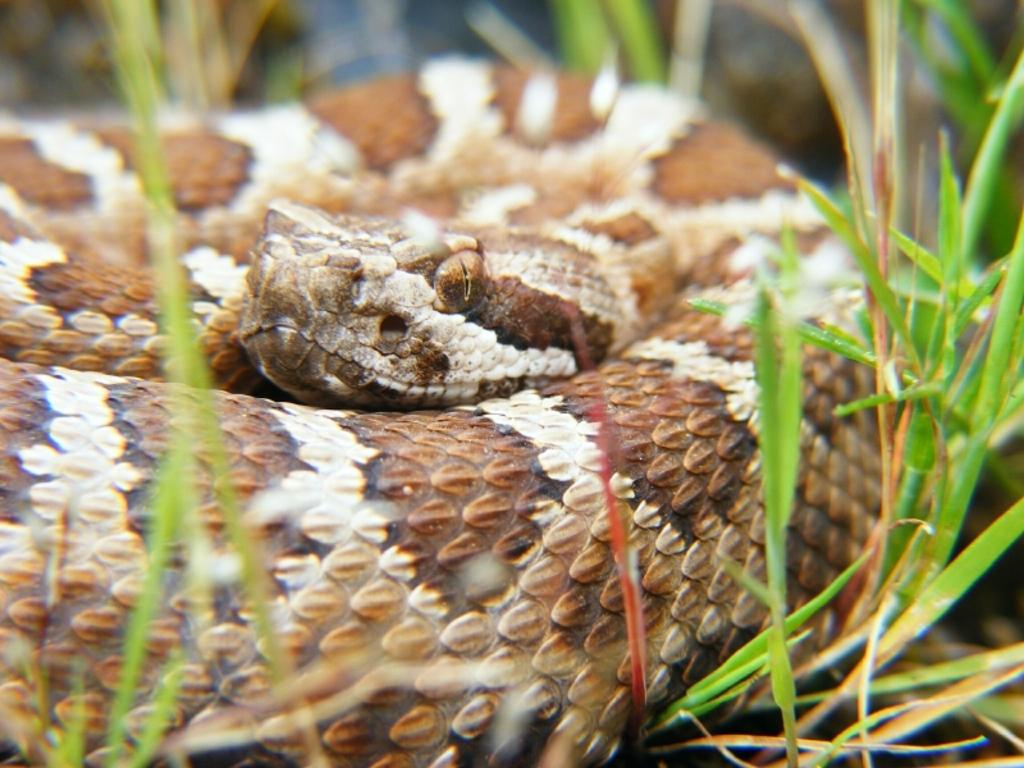What type of animal is in the image? There is a snake in the image. Where is the snake located? The snake is on the ground. What type of vegetation is present in the image? There is grass in the image. How many horses can be seen interacting with the monkey in the image? There are no horses or monkeys present in the image; it features a snake on the ground with grass. 